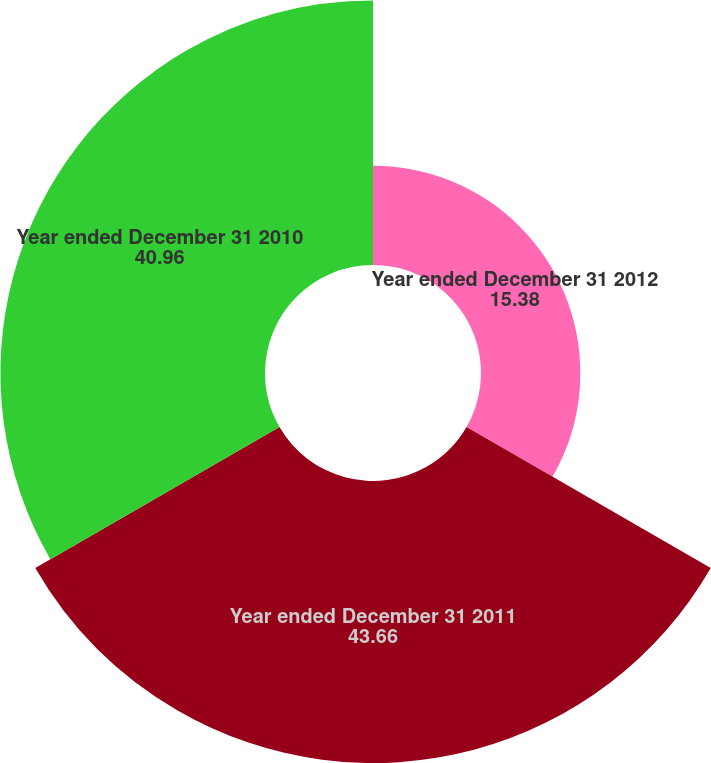<chart> <loc_0><loc_0><loc_500><loc_500><pie_chart><fcel>Year ended December 31 2012<fcel>Year ended December 31 2011<fcel>Year ended December 31 2010<nl><fcel>15.38%<fcel>43.66%<fcel>40.96%<nl></chart> 